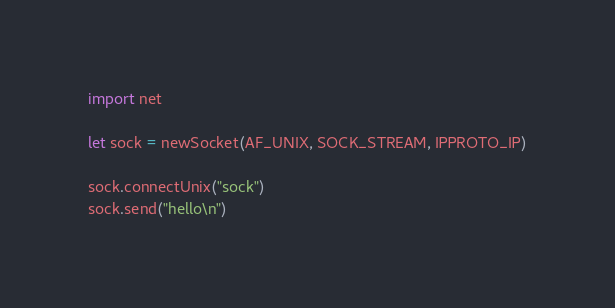<code> <loc_0><loc_0><loc_500><loc_500><_Nim_>import net

let sock = newSocket(AF_UNIX, SOCK_STREAM, IPPROTO_IP)

sock.connectUnix("sock")
sock.send("hello\n")
</code> 